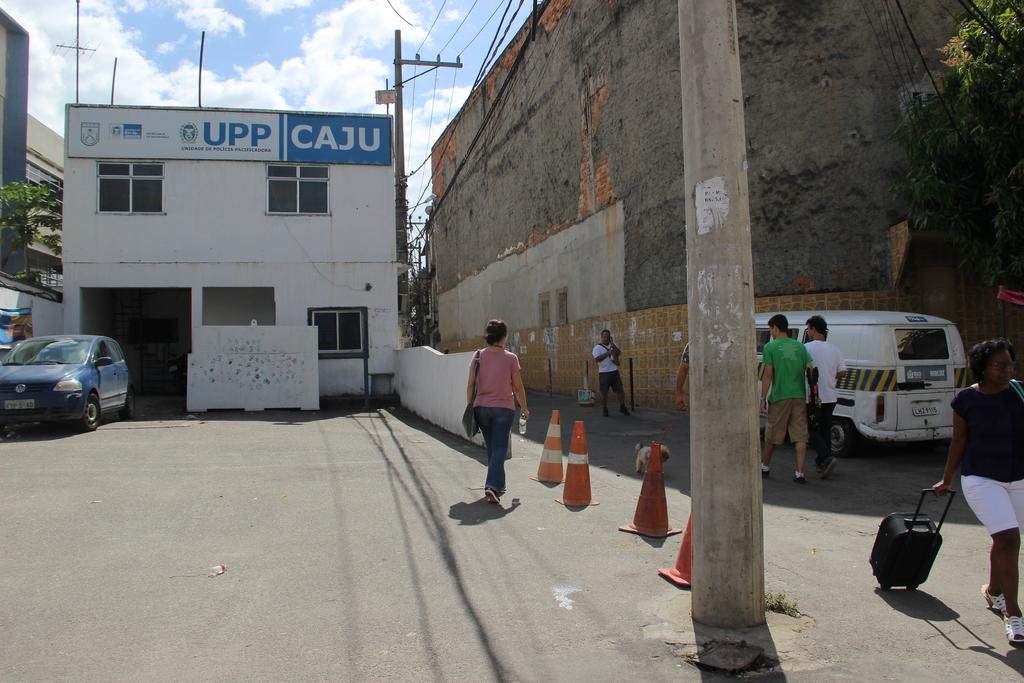<image>
Share a concise interpretation of the image provided. the word caju that is on a building 